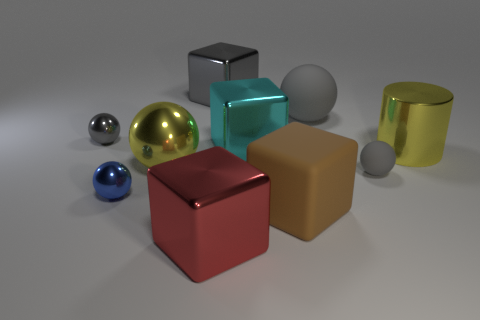What color is the big rubber sphere?
Provide a short and direct response. Gray. There is a matte thing that is the same color as the large rubber ball; what shape is it?
Give a very brief answer. Sphere. There is a cylinder that is the same size as the gray cube; what is its color?
Offer a very short reply. Yellow. How many matte things are either small gray balls or gray cubes?
Provide a short and direct response. 1. What number of objects are left of the big metal cylinder and in front of the large gray cube?
Your answer should be compact. 8. Is there anything else that has the same shape as the big cyan object?
Provide a short and direct response. Yes. What number of other objects are there of the same size as the cyan shiny object?
Offer a very short reply. 6. There is a gray matte object in front of the large gray matte object; is its size the same as the shiny sphere that is on the right side of the blue metallic thing?
Give a very brief answer. No. How many objects are either big yellow things or things that are in front of the large metal cylinder?
Your response must be concise. 6. There is a gray object that is left of the yellow sphere; what size is it?
Your answer should be very brief. Small. 